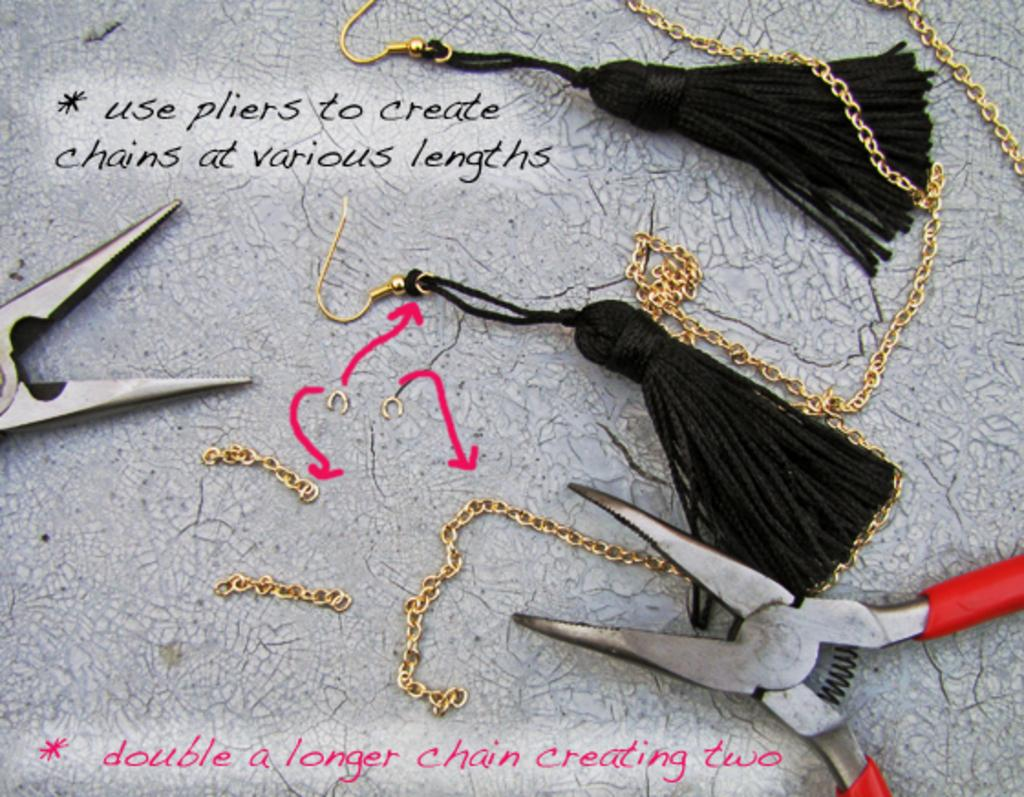What type of jewelry is present in the image? There are earrings in the image. What electronic device is visible in the image? There is a cutting player in the image. What object is placed on a surface in the image? There is a clip placed on a surface in the image. What type of accessory is visible in the image? There are chains visible in the image. What can be read or seen in the image? There is text written in the image. How many birds are sitting on the boat in the image? There is no boat or birds present in the image. What type of comfort can be seen in the image? There is no reference to comfort in the image. 